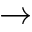<formula> <loc_0><loc_0><loc_500><loc_500>\to</formula> 